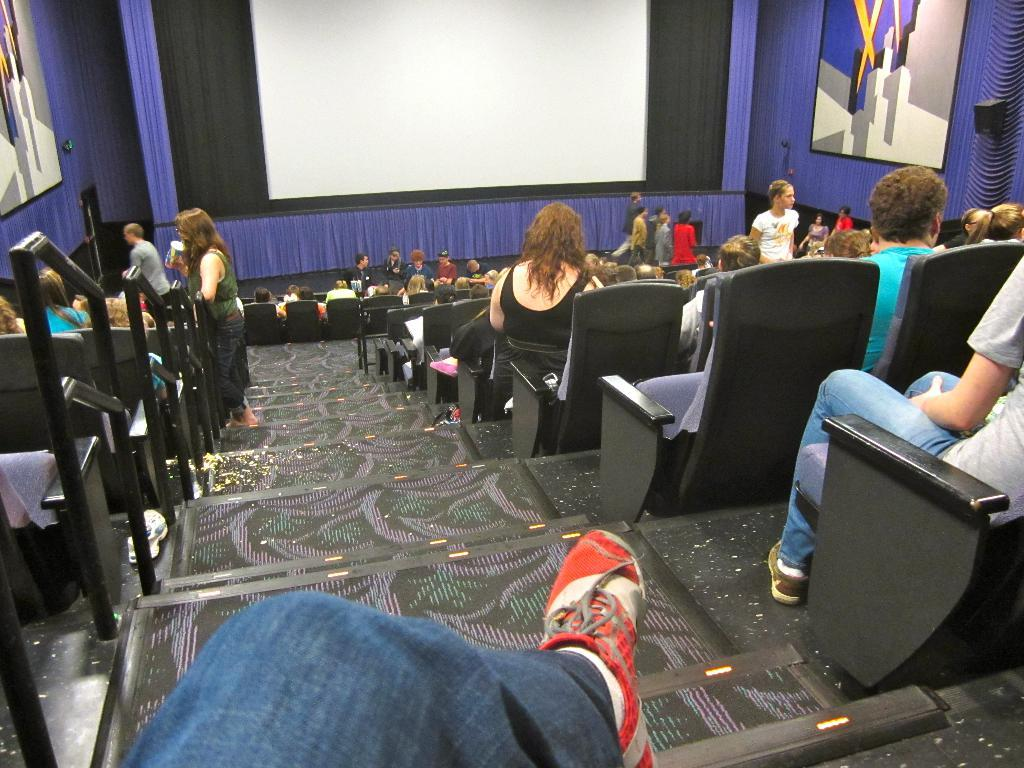What can be seen in the image that people use to move between different levels? There are steps in the image that people use to move between different levels. What objects are near the steps? There are chairs near the steps. How are the chairs being used in the image? There are many people sitting on the chairs. What is visible in the background of the image? There is a screen and curtains in the background of the image. What type of tin can be seen being smashed by the people sitting on the chairs? There is no tin present in the image, nor is anyone smashing anything. Can you tell me the name of the aunt sitting on the chair in the image? There is no mention of an aunt or any specific person in the image. 